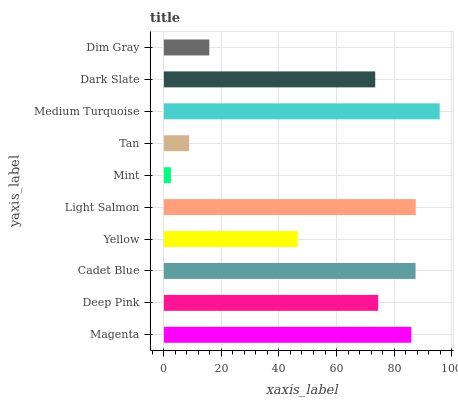Is Mint the minimum?
Answer yes or no. Yes. Is Medium Turquoise the maximum?
Answer yes or no. Yes. Is Deep Pink the minimum?
Answer yes or no. No. Is Deep Pink the maximum?
Answer yes or no. No. Is Magenta greater than Deep Pink?
Answer yes or no. Yes. Is Deep Pink less than Magenta?
Answer yes or no. Yes. Is Deep Pink greater than Magenta?
Answer yes or no. No. Is Magenta less than Deep Pink?
Answer yes or no. No. Is Deep Pink the high median?
Answer yes or no. Yes. Is Dark Slate the low median?
Answer yes or no. Yes. Is Medium Turquoise the high median?
Answer yes or no. No. Is Light Salmon the low median?
Answer yes or no. No. 